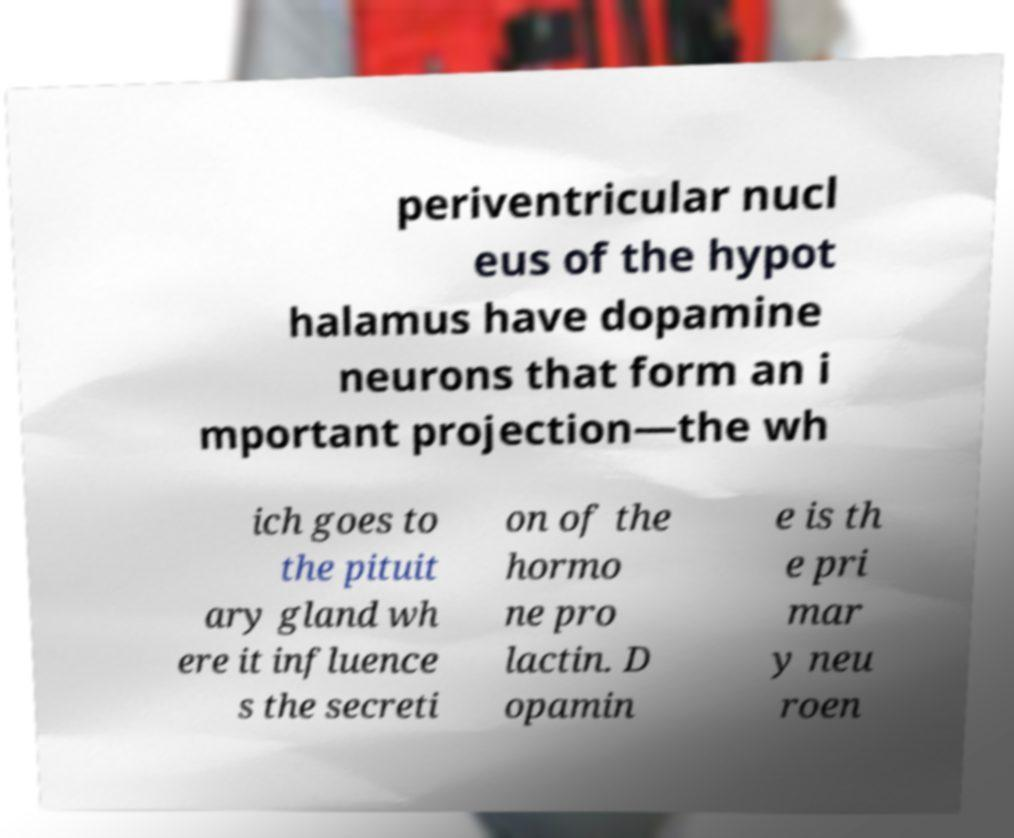Please read and relay the text visible in this image. What does it say? periventricular nucl eus of the hypot halamus have dopamine neurons that form an i mportant projection—the wh ich goes to the pituit ary gland wh ere it influence s the secreti on of the hormo ne pro lactin. D opamin e is th e pri mar y neu roen 